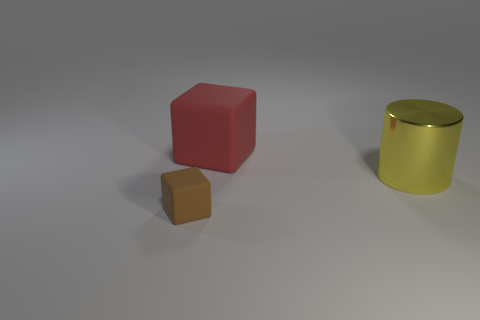Add 2 purple cylinders. How many objects exist? 5 Subtract all cylinders. How many objects are left? 2 Subtract all red cubes. Subtract all blue metal balls. How many objects are left? 2 Add 3 brown matte things. How many brown matte things are left? 4 Add 3 big green metallic cubes. How many big green metallic cubes exist? 3 Subtract 0 purple cylinders. How many objects are left? 3 